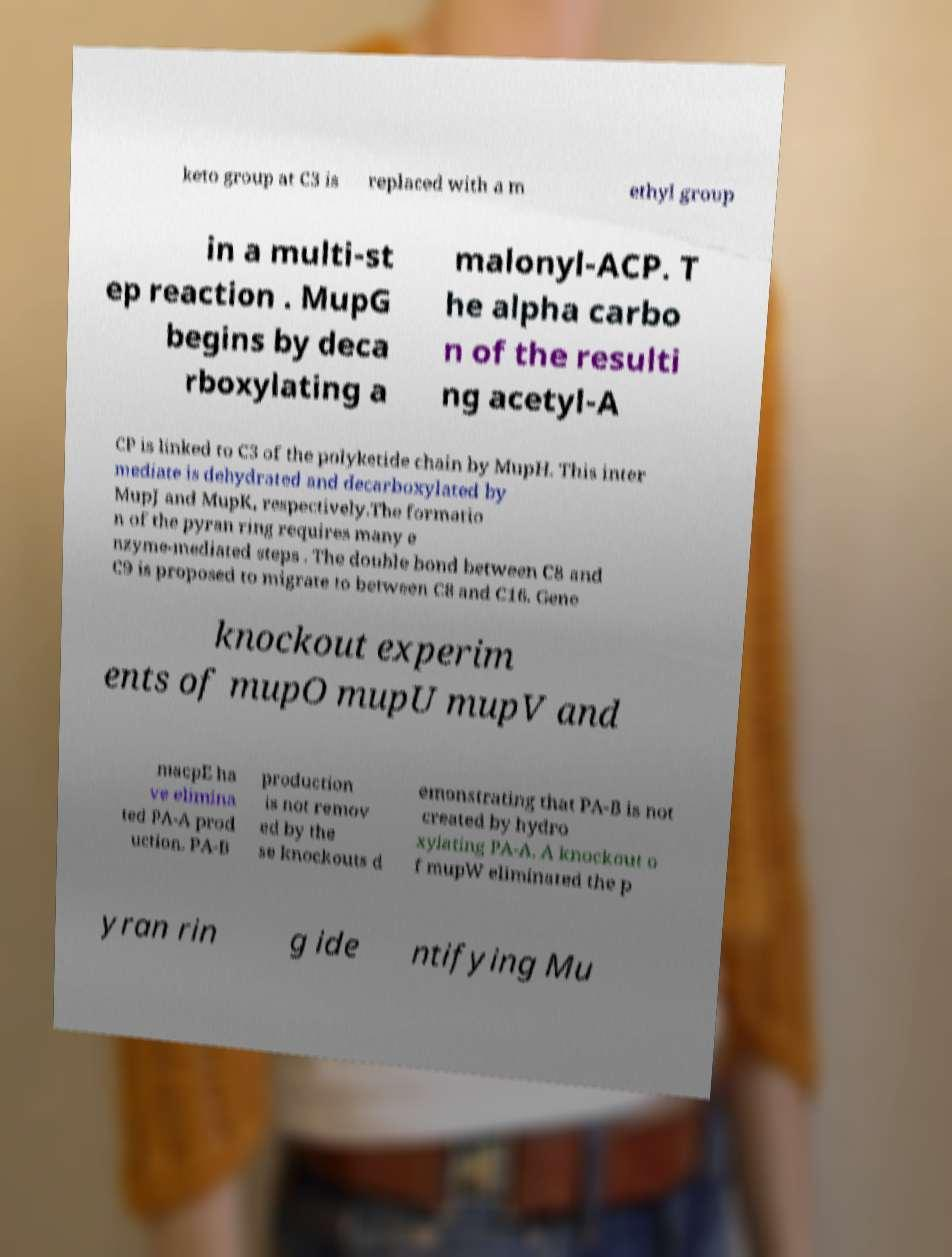What messages or text are displayed in this image? I need them in a readable, typed format. keto group at C3 is replaced with a m ethyl group in a multi-st ep reaction . MupG begins by deca rboxylating a malonyl-ACP. T he alpha carbo n of the resulti ng acetyl-A CP is linked to C3 of the polyketide chain by MupH. This inter mediate is dehydrated and decarboxylated by MupJ and MupK, respectively.The formatio n of the pyran ring requires many e nzyme-mediated steps . The double bond between C8 and C9 is proposed to migrate to between C8 and C16. Gene knockout experim ents of mupO mupU mupV and macpE ha ve elimina ted PA-A prod uction. PA-B production is not remov ed by the se knockouts d emonstrating that PA-B is not created by hydro xylating PA-A. A knockout o f mupW eliminated the p yran rin g ide ntifying Mu 